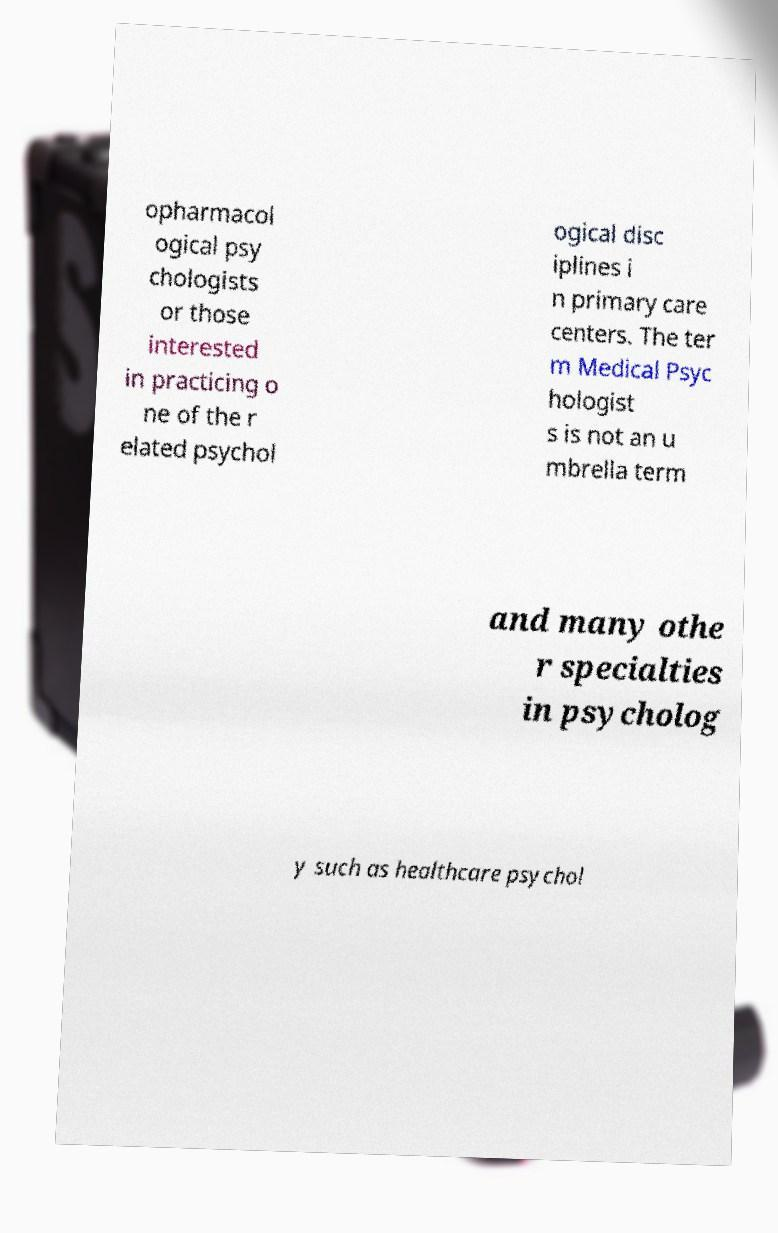Could you extract and type out the text from this image? opharmacol ogical psy chologists or those interested in practicing o ne of the r elated psychol ogical disc iplines i n primary care centers. The ter m Medical Psyc hologist s is not an u mbrella term and many othe r specialties in psycholog y such as healthcare psychol 